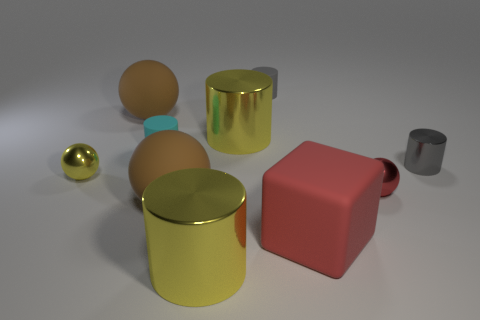How many brown balls must be subtracted to get 1 brown balls? 1 Subtract all tiny cyan cylinders. How many cylinders are left? 4 Subtract all cyan cylinders. How many cylinders are left? 4 Subtract 2 cylinders. How many cylinders are left? 3 Subtract all cyan spheres. Subtract all cyan cylinders. How many spheres are left? 4 Subtract all balls. How many objects are left? 6 Add 5 yellow matte blocks. How many yellow matte blocks exist? 5 Subtract 0 blue cylinders. How many objects are left? 10 Subtract all tiny gray matte cylinders. Subtract all large matte things. How many objects are left? 6 Add 8 cyan things. How many cyan things are left? 9 